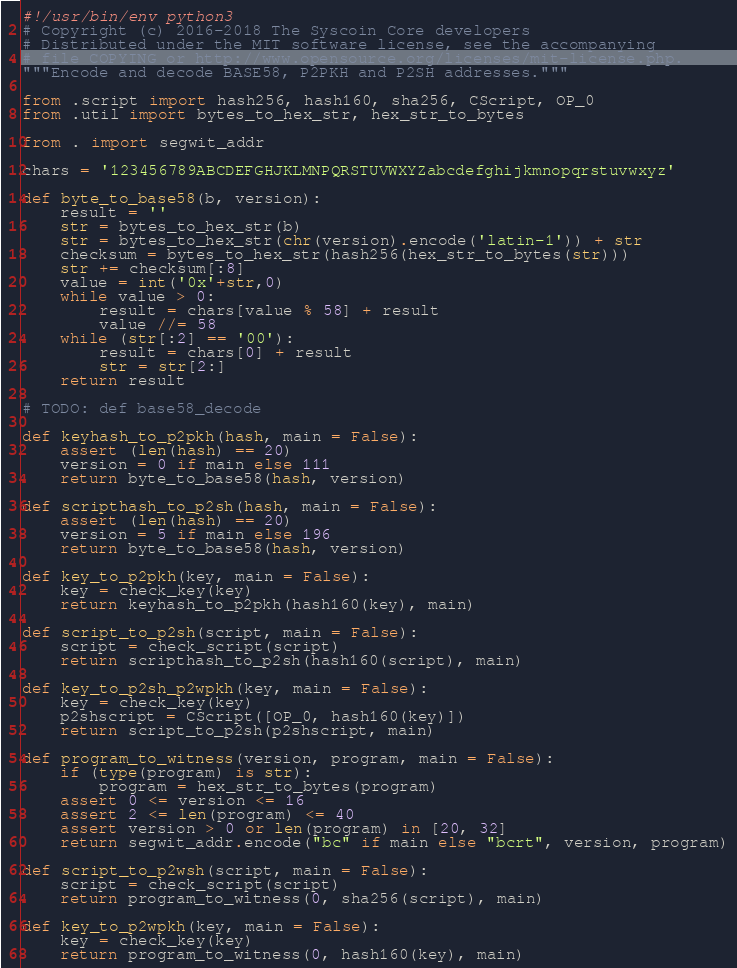Convert code to text. <code><loc_0><loc_0><loc_500><loc_500><_Python_>#!/usr/bin/env python3
# Copyright (c) 2016-2018 The Syscoin Core developers
# Distributed under the MIT software license, see the accompanying
# file COPYING or http://www.opensource.org/licenses/mit-license.php.
"""Encode and decode BASE58, P2PKH and P2SH addresses."""

from .script import hash256, hash160, sha256, CScript, OP_0
from .util import bytes_to_hex_str, hex_str_to_bytes

from . import segwit_addr

chars = '123456789ABCDEFGHJKLMNPQRSTUVWXYZabcdefghijkmnopqrstuvwxyz'

def byte_to_base58(b, version):
    result = ''
    str = bytes_to_hex_str(b)
    str = bytes_to_hex_str(chr(version).encode('latin-1')) + str
    checksum = bytes_to_hex_str(hash256(hex_str_to_bytes(str)))
    str += checksum[:8]
    value = int('0x'+str,0)
    while value > 0:
        result = chars[value % 58] + result
        value //= 58
    while (str[:2] == '00'):
        result = chars[0] + result
        str = str[2:]
    return result

# TODO: def base58_decode

def keyhash_to_p2pkh(hash, main = False):
    assert (len(hash) == 20)
    version = 0 if main else 111
    return byte_to_base58(hash, version)

def scripthash_to_p2sh(hash, main = False):
    assert (len(hash) == 20)
    version = 5 if main else 196
    return byte_to_base58(hash, version)

def key_to_p2pkh(key, main = False):
    key = check_key(key)
    return keyhash_to_p2pkh(hash160(key), main)

def script_to_p2sh(script, main = False):
    script = check_script(script)
    return scripthash_to_p2sh(hash160(script), main)

def key_to_p2sh_p2wpkh(key, main = False):
    key = check_key(key)
    p2shscript = CScript([OP_0, hash160(key)])
    return script_to_p2sh(p2shscript, main)

def program_to_witness(version, program, main = False):
    if (type(program) is str):
        program = hex_str_to_bytes(program)
    assert 0 <= version <= 16
    assert 2 <= len(program) <= 40
    assert version > 0 or len(program) in [20, 32]
    return segwit_addr.encode("bc" if main else "bcrt", version, program)

def script_to_p2wsh(script, main = False):
    script = check_script(script)
    return program_to_witness(0, sha256(script), main)

def key_to_p2wpkh(key, main = False):
    key = check_key(key)
    return program_to_witness(0, hash160(key), main)
</code> 